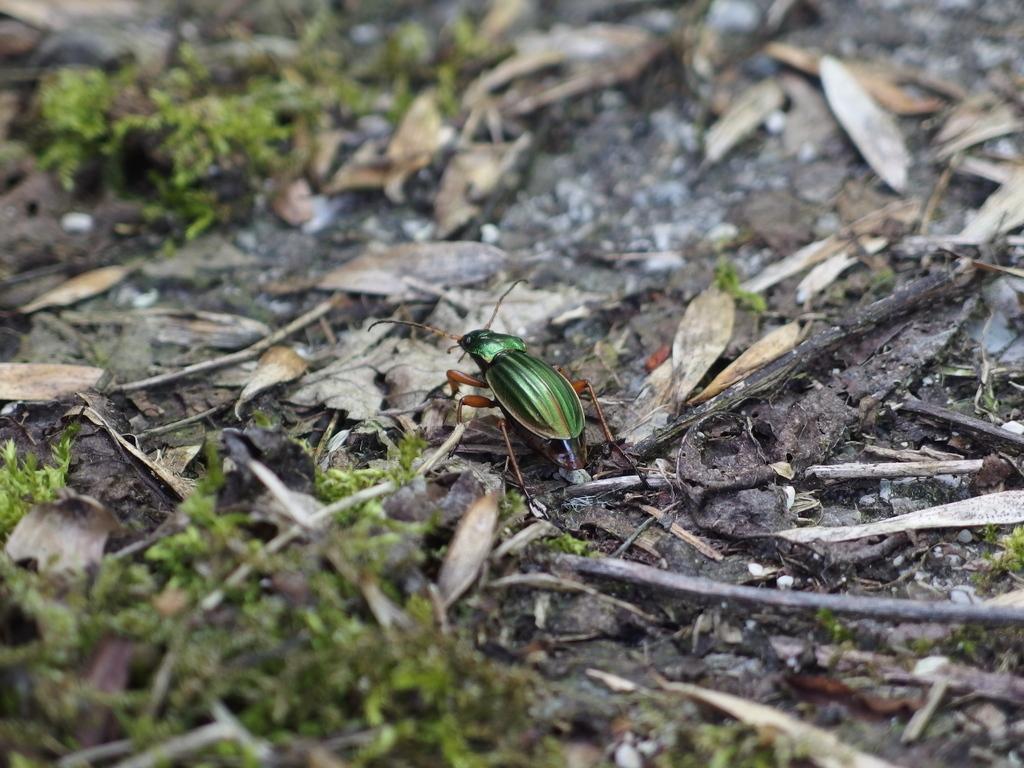Please provide a concise description of this image. In this image we can see an insect on the leaves on the ground and we can also see sticks and grass on the ground. 